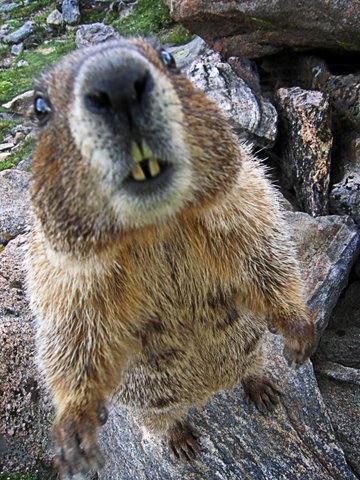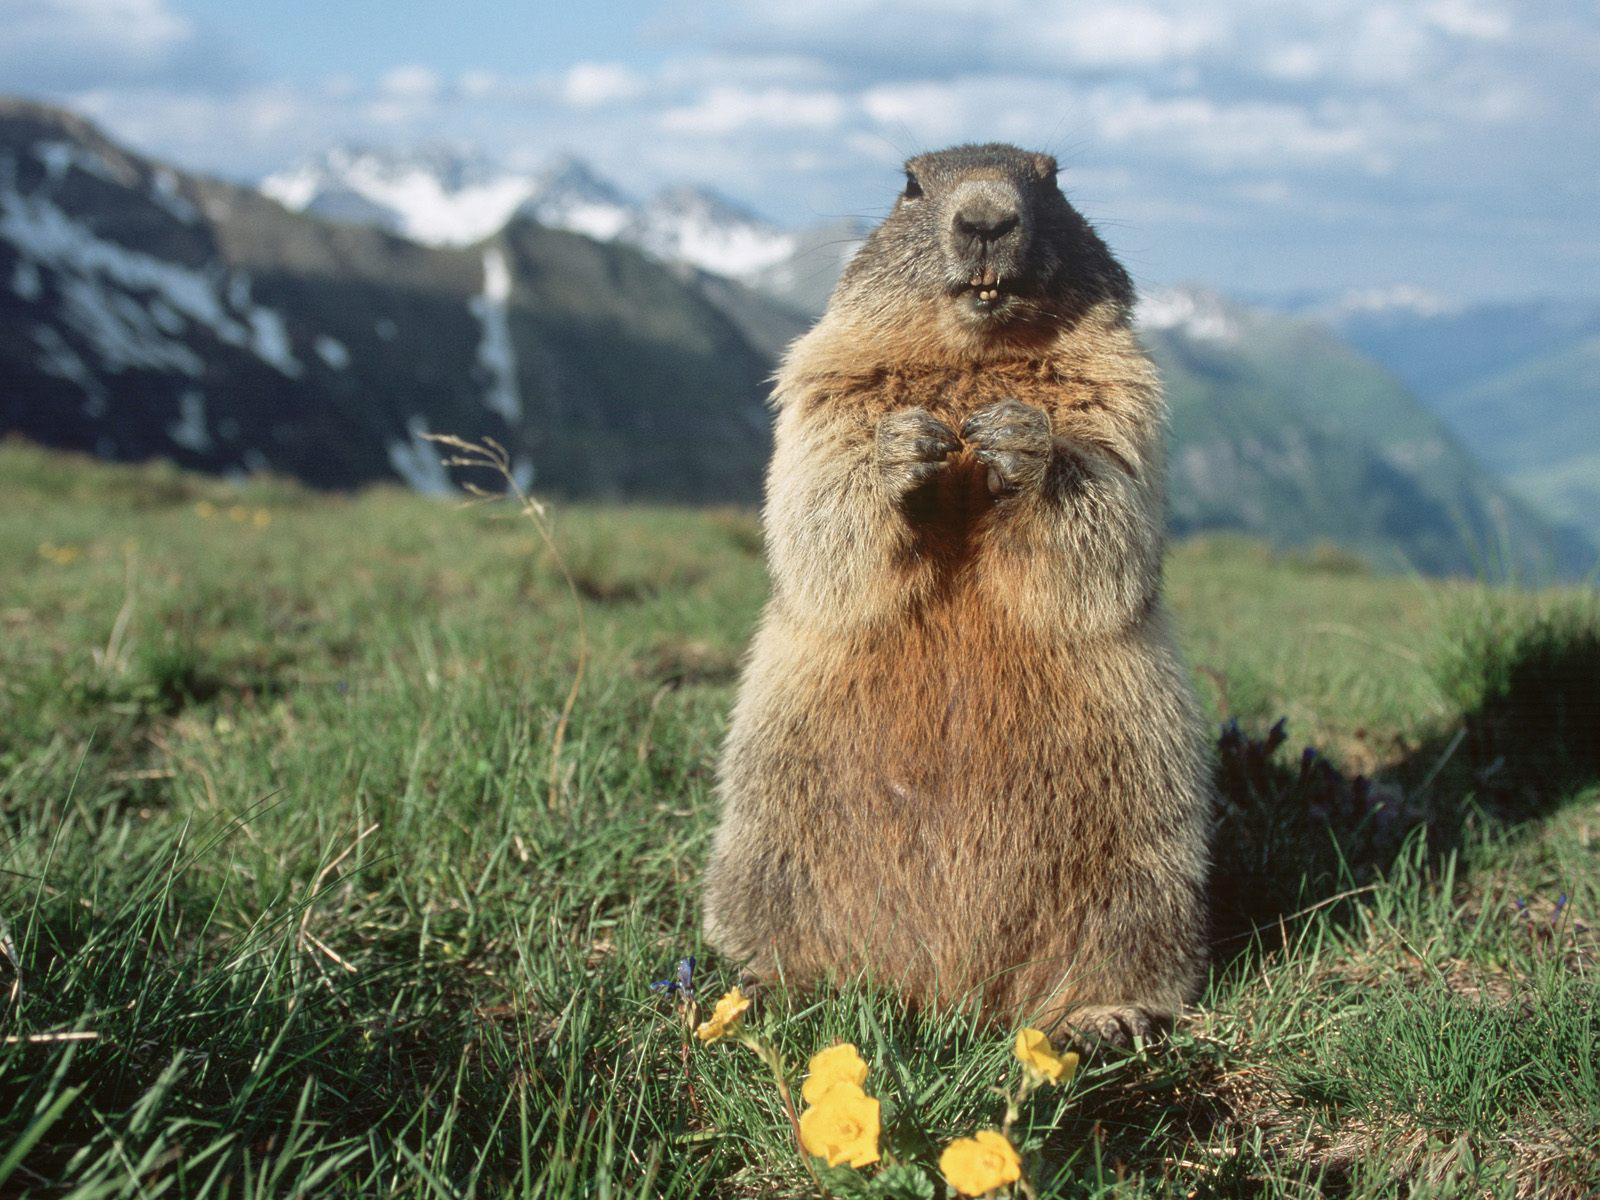The first image is the image on the left, the second image is the image on the right. Evaluate the accuracy of this statement regarding the images: "The right image contains a rodent standing on grass.". Is it true? Answer yes or no. Yes. The first image is the image on the left, the second image is the image on the right. Evaluate the accuracy of this statement regarding the images: "A marmot is standing with its front paws raised towards its mouth in a clasping pose.". Is it true? Answer yes or no. Yes. 